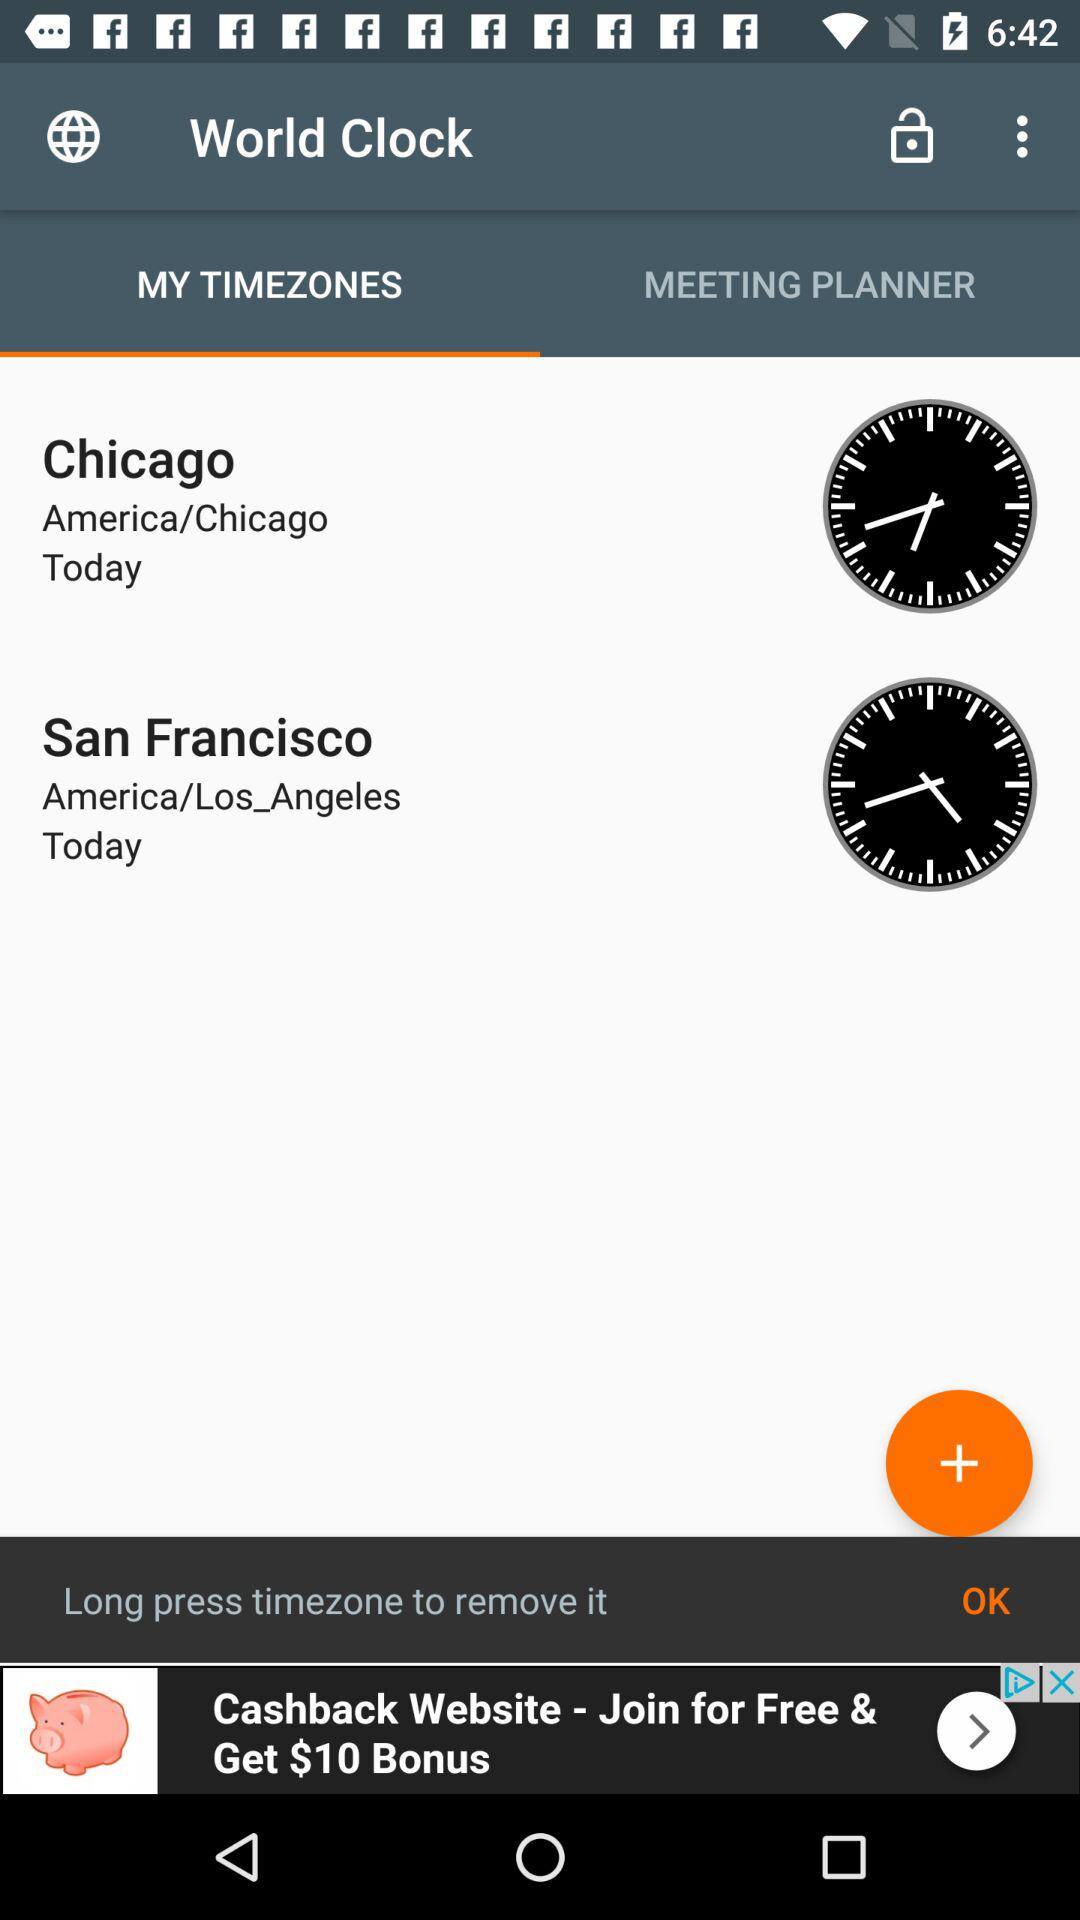What is today's time showing in Chicago?
When the provided information is insufficient, respond with <no answer>. <no answer> 